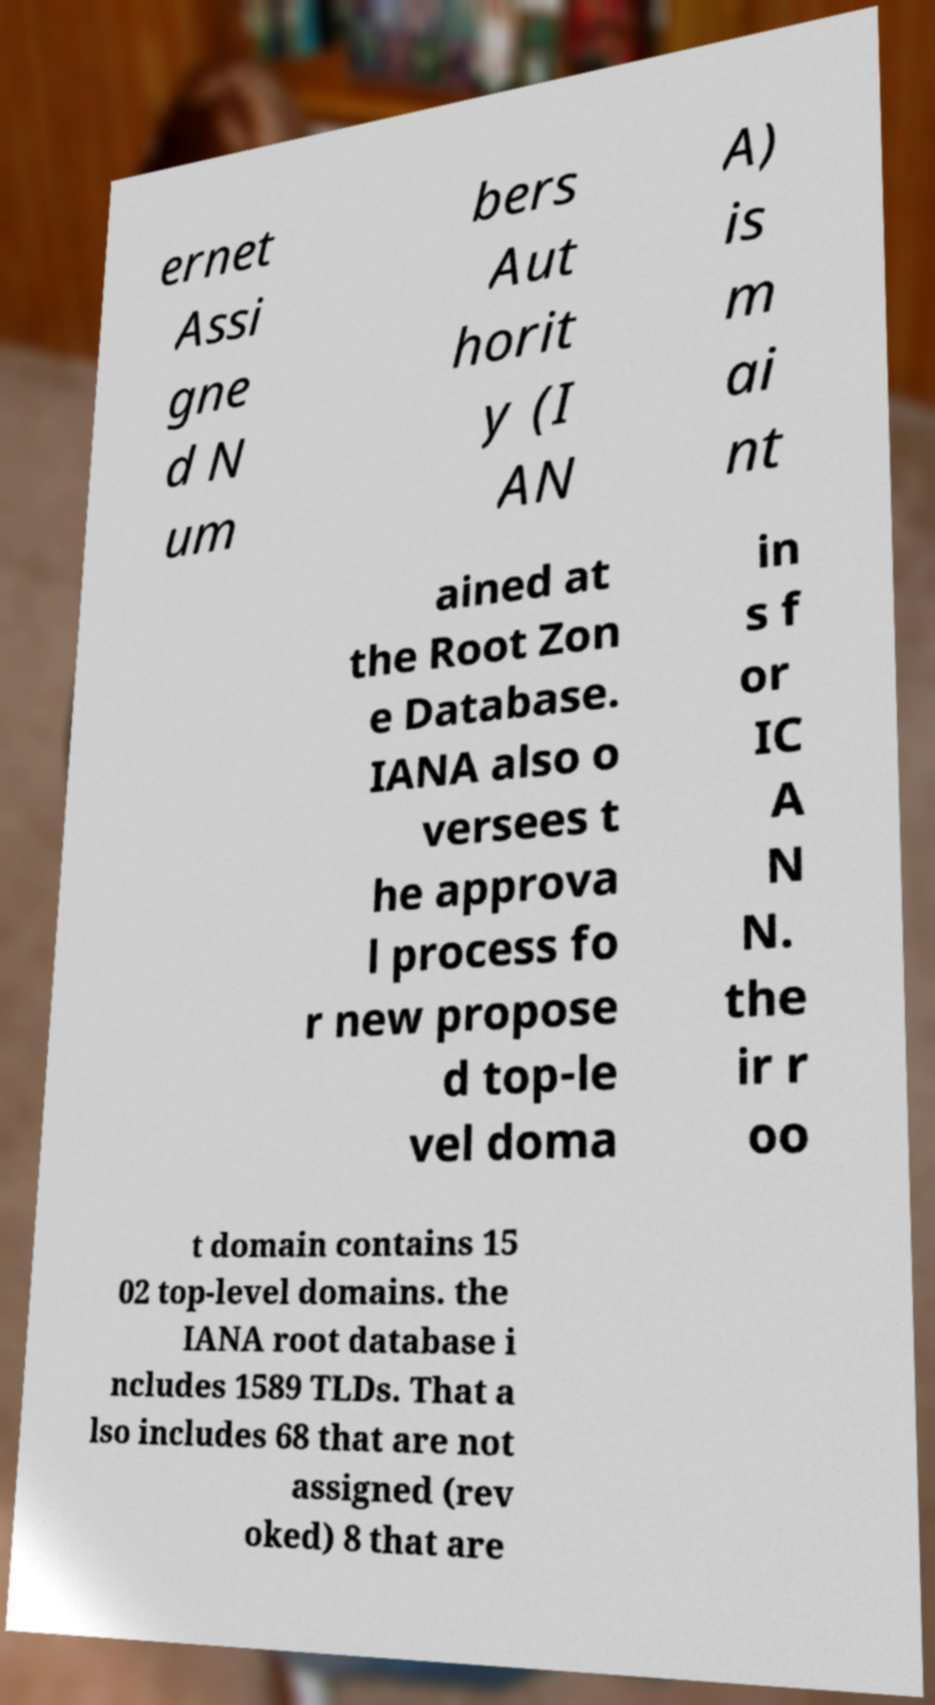I need the written content from this picture converted into text. Can you do that? ernet Assi gne d N um bers Aut horit y (I AN A) is m ai nt ained at the Root Zon e Database. IANA also o versees t he approva l process fo r new propose d top-le vel doma in s f or IC A N N. the ir r oo t domain contains 15 02 top-level domains. the IANA root database i ncludes 1589 TLDs. That a lso includes 68 that are not assigned (rev oked) 8 that are 